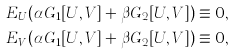Convert formula to latex. <formula><loc_0><loc_0><loc_500><loc_500>E _ { U } ( \alpha G _ { 1 } [ U , V ] + \beta G _ { 2 } [ U , V ] ) \equiv 0 , \\ E _ { V } ( \alpha G _ { 1 } [ U , V ] + \beta G _ { 2 } [ U , V ] ) \equiv 0 ,</formula> 